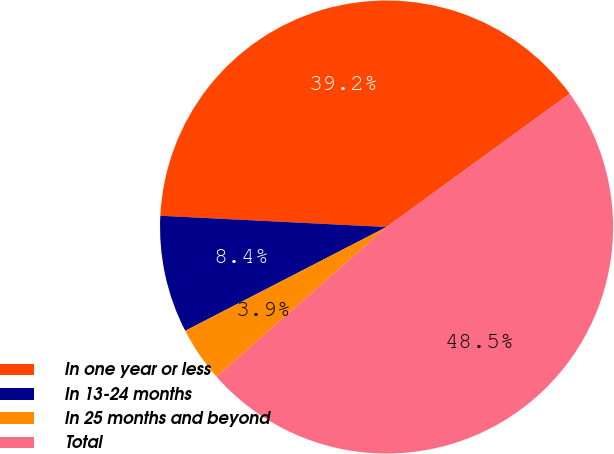Convert chart to OTSL. <chart><loc_0><loc_0><loc_500><loc_500><pie_chart><fcel>In one year or less<fcel>In 13-24 months<fcel>In 25 months and beyond<fcel>Total<nl><fcel>39.2%<fcel>8.37%<fcel>3.91%<fcel>48.53%<nl></chart> 